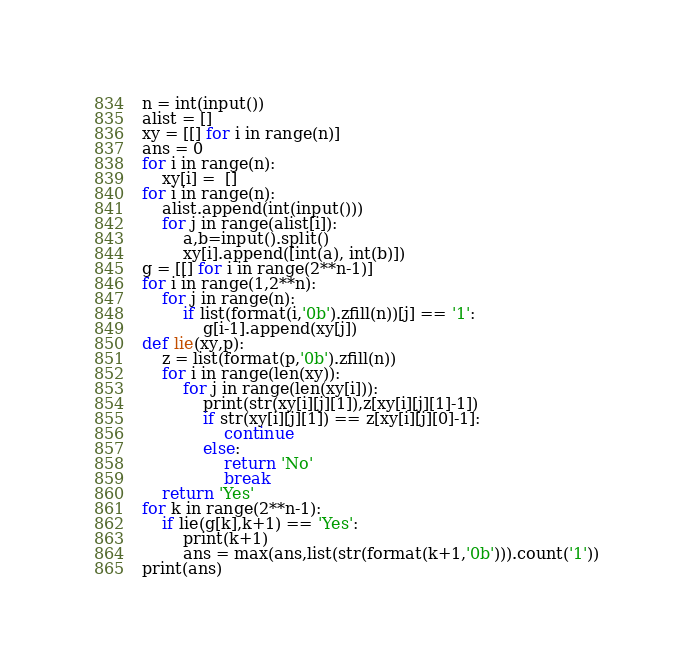Convert code to text. <code><loc_0><loc_0><loc_500><loc_500><_Python_>n = int(input())
alist = []
xy = [[] for i in range(n)]
ans = 0
for i in range(n):
    xy[i] =  []
for i in range(n):
    alist.append(int(input()))
    for j in range(alist[i]):
        a,b=input().split()
        xy[i].append([int(a), int(b)])
g = [[] for i in range(2**n-1)]
for i in range(1,2**n):
    for j in range(n):
        if list(format(i,'0b').zfill(n))[j] == '1':
            g[i-1].append(xy[j])
def lie(xy,p):
    z = list(format(p,'0b').zfill(n)) 
    for i in range(len(xy)):
        for j in range(len(xy[i])):
            print(str(xy[i][j][1]),z[xy[i][j][1]-1])
            if str(xy[i][j][1]) == z[xy[i][j][0]-1]:
                continue
            else:
                return 'No'
                break
    return 'Yes'
for k in range(2**n-1):
    if lie(g[k],k+1) == 'Yes':
        print(k+1)
        ans = max(ans,list(str(format(k+1,'0b'))).count('1'))
print(ans)</code> 